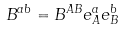Convert formula to latex. <formula><loc_0><loc_0><loc_500><loc_500>B ^ { a b } = B ^ { A B } e _ { A } ^ { a } e _ { B } ^ { b }</formula> 